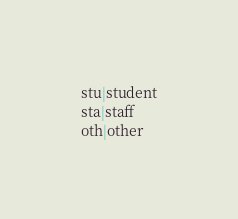<code> <loc_0><loc_0><loc_500><loc_500><_SQL_>stu|student
sta|staff
oth|other
</code> 